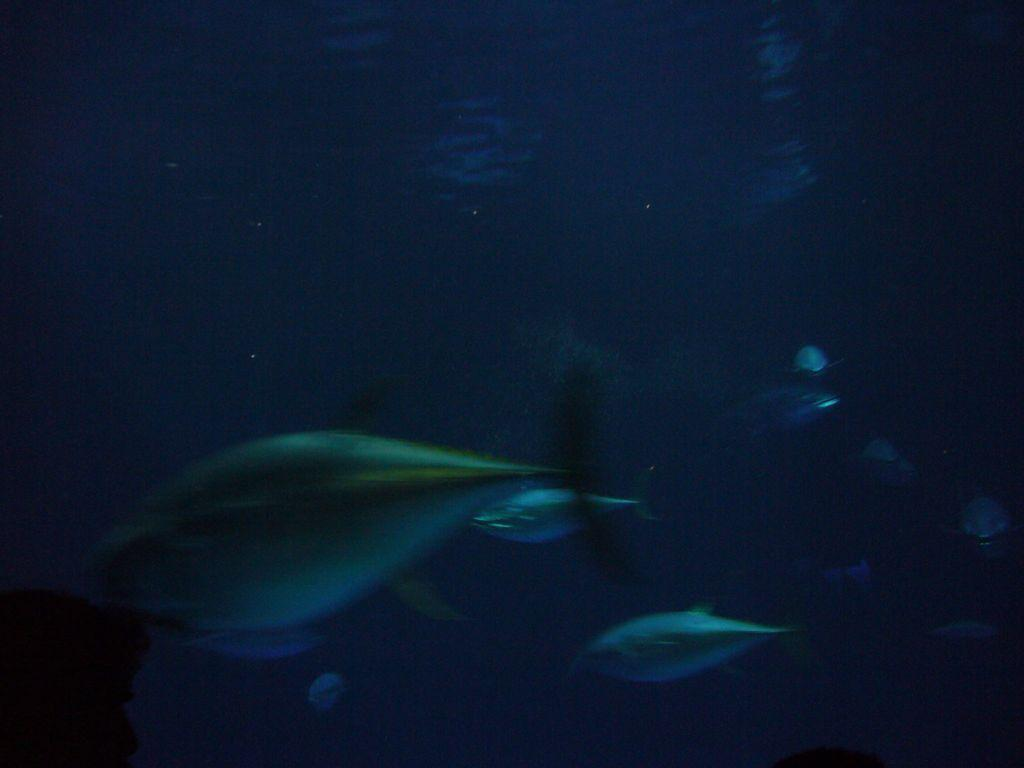What type of environment is depicted in the image? The image contains deep water. What can be seen swimming in the water? There are fishes visible in the water. What direction is the zephyr blowing in the image? There is no mention of a zephyr in the image, as it is a deep water environment with fishes. 